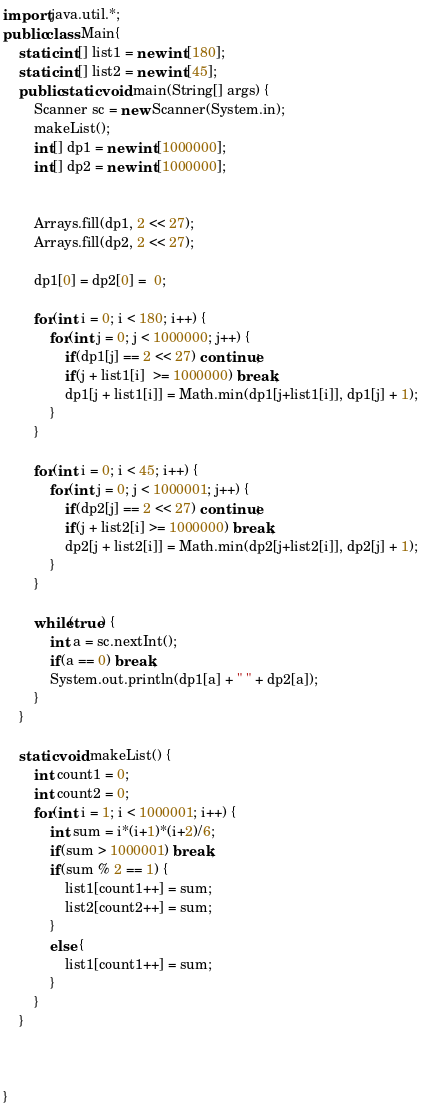<code> <loc_0><loc_0><loc_500><loc_500><_Java_>import java.util.*;
public class Main{
	static int[] list1 = new int[180];
	static int[] list2 = new int[45];
	public static void main(String[] args) {
		Scanner sc = new Scanner(System.in);
		makeList();
		int[] dp1 = new int[1000000];
		int[] dp2 = new int[1000000]; 
		

		Arrays.fill(dp1, 2 << 27);
		Arrays.fill(dp2, 2 << 27);

		dp1[0] = dp2[0] =  0;

		for(int i = 0; i < 180; i++) {
			for(int j = 0; j < 1000000; j++) {
				if(dp1[j] == 2 << 27) continue;
				if(j + list1[i]  >= 1000000) break;
				dp1[j + list1[i]] = Math.min(dp1[j+list1[i]], dp1[j] + 1);
			}
		}

		for(int i = 0; i < 45; i++) {
			for(int j = 0; j < 1000001; j++) {
				if(dp2[j] == 2 << 27) continue;
				if(j + list2[i] >= 1000000) break;
				dp2[j + list2[i]] = Math.min(dp2[j+list2[i]], dp2[j] + 1);
			}
		}
		
		while(true) {
			int a = sc.nextInt();
			if(a == 0) break;
			System.out.println(dp1[a] + " " + dp2[a]);
		}
	}
	
	static void makeList() {
		int count1 = 0;
		int count2 = 0;
		for(int i = 1; i < 1000001; i++) {
			int sum = i*(i+1)*(i+2)/6;
			if(sum > 1000001) break;
			if(sum % 2 == 1) {
				list1[count1++] = sum;
				list2[count2++] = sum;
			}
			else {
				list1[count1++] = sum;
			}
		}
	}
	

	
}</code> 